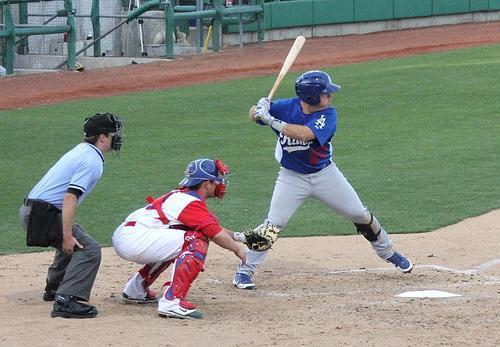How many baseball players are in the picture?
Give a very brief answer. 2. 